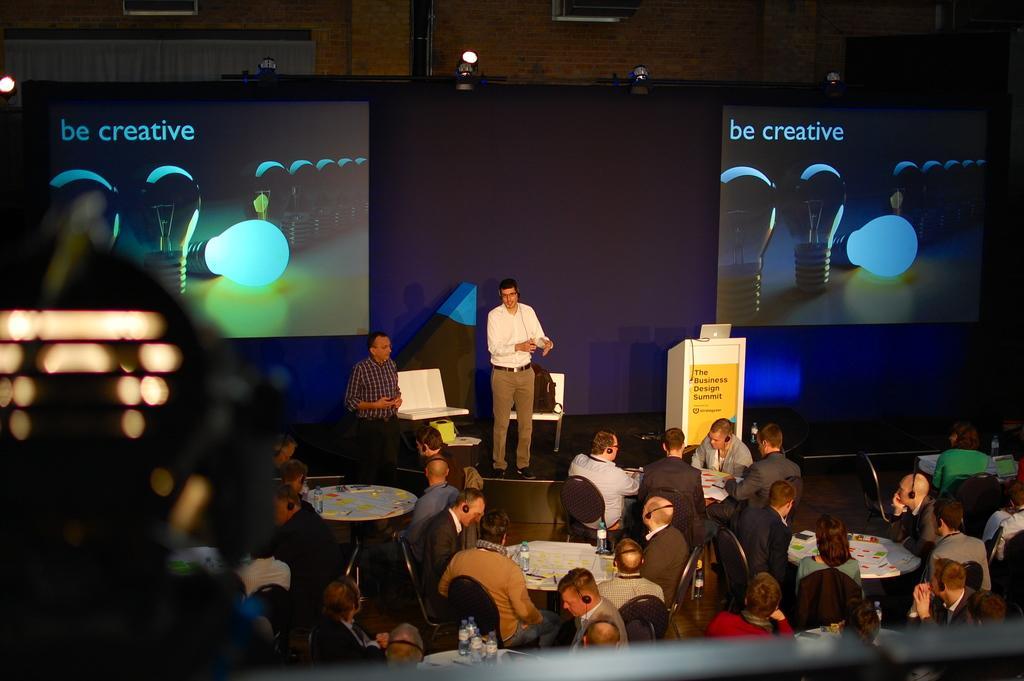How would you summarize this image in a sentence or two? The picture is taken during a conference. In the foreground there is a railing and an object. At the center of the picture there are people sitting in chairs and there are tables, on the tables they are water bottles. In the background there is a stage, on the stage there are a podium, laptop, chairs and people. At the top there are lights, brick wall, windows, curtains and banners. 